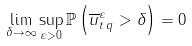Convert formula to latex. <formula><loc_0><loc_0><loc_500><loc_500>\lim _ { \delta \rightarrow \infty } \sup _ { \varepsilon > 0 } \mathbb { P } \left ( { \| \overline { u } _ { t } ^ { \varepsilon } \| } _ { q } > \delta \right ) = 0</formula> 